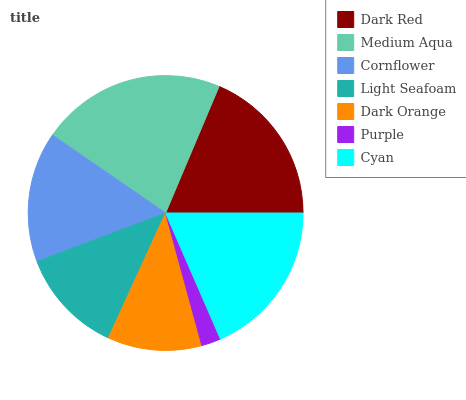Is Purple the minimum?
Answer yes or no. Yes. Is Medium Aqua the maximum?
Answer yes or no. Yes. Is Cornflower the minimum?
Answer yes or no. No. Is Cornflower the maximum?
Answer yes or no. No. Is Medium Aqua greater than Cornflower?
Answer yes or no. Yes. Is Cornflower less than Medium Aqua?
Answer yes or no. Yes. Is Cornflower greater than Medium Aqua?
Answer yes or no. No. Is Medium Aqua less than Cornflower?
Answer yes or no. No. Is Cornflower the high median?
Answer yes or no. Yes. Is Cornflower the low median?
Answer yes or no. Yes. Is Purple the high median?
Answer yes or no. No. Is Purple the low median?
Answer yes or no. No. 